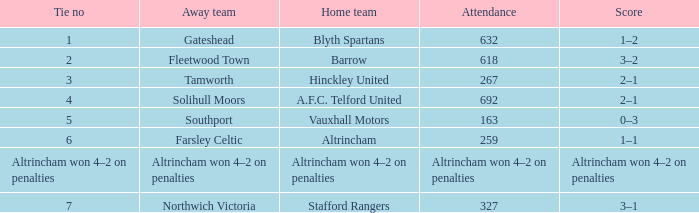Which home team had the away team Southport? Vauxhall Motors. 